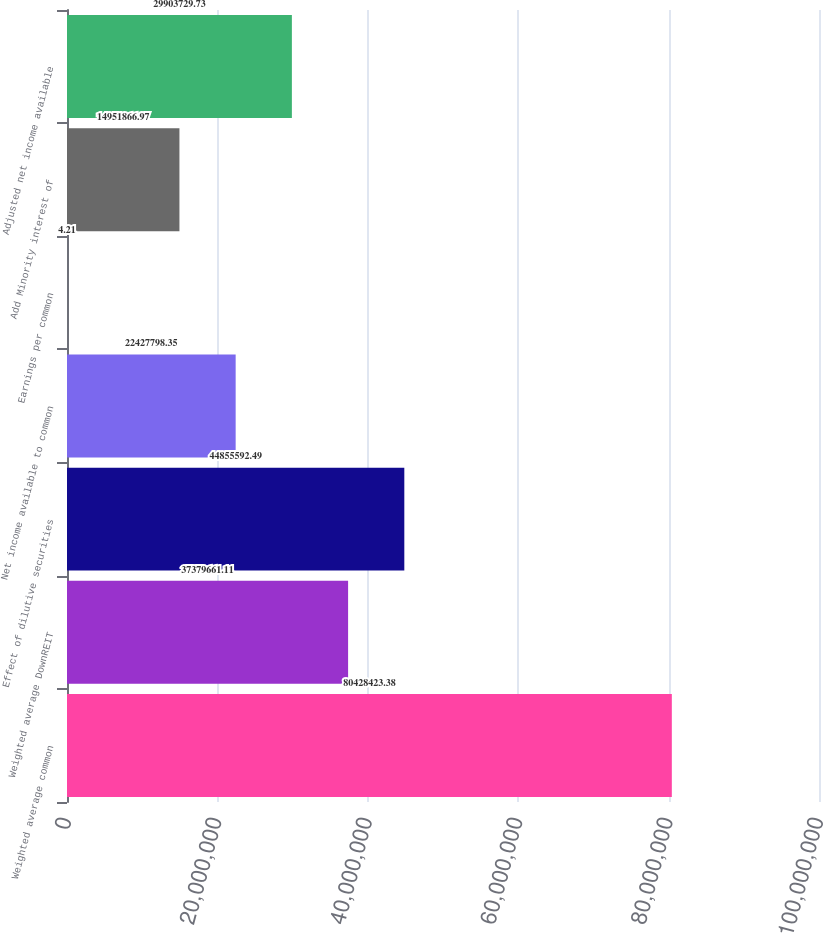Convert chart. <chart><loc_0><loc_0><loc_500><loc_500><bar_chart><fcel>Weighted average common<fcel>Weighted average DownREIT<fcel>Effect of dilutive securities<fcel>Net income available to common<fcel>Earnings per common<fcel>Add Minority interest of<fcel>Adjusted net income available<nl><fcel>8.04284e+07<fcel>3.73797e+07<fcel>4.48556e+07<fcel>2.24278e+07<fcel>4.21<fcel>1.49519e+07<fcel>2.99037e+07<nl></chart> 